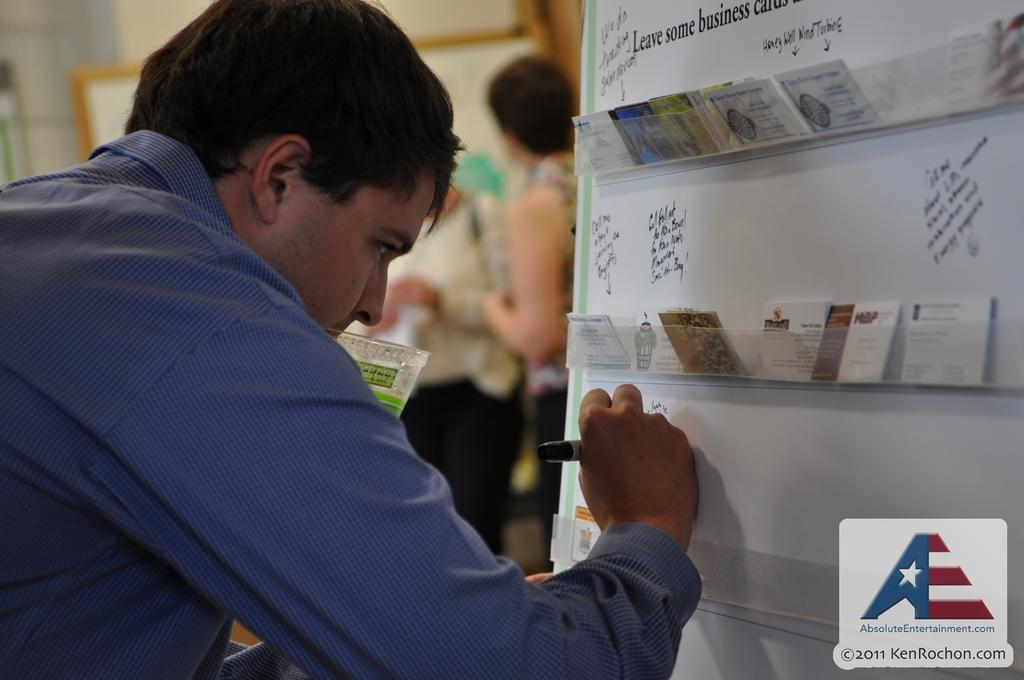Who is the main subject in the image? There is a man in the image. What is the man doing in the image? The man is writing on a whiteboard. Can you describe the background of the image? There are people standing in the background of the image. What type of chicken is visible in the image? There is no chicken present in the image. Is the man wearing a sweater while writing on the whiteboard? The provided facts do not mention the man's clothing, so we cannot determine if he is wearing a sweater. 